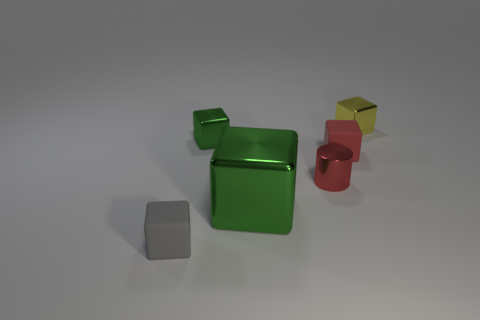Subtract all gray cubes. How many cubes are left? 4 Subtract all big green metallic blocks. How many blocks are left? 4 Subtract all cyan cubes. Subtract all blue spheres. How many cubes are left? 5 Add 1 small red shiny objects. How many objects exist? 7 Subtract all cubes. How many objects are left? 1 Add 4 tiny red rubber blocks. How many tiny red rubber blocks are left? 5 Add 3 tiny metallic cylinders. How many tiny metallic cylinders exist? 4 Subtract 0 cyan balls. How many objects are left? 6 Subtract all yellow metal cubes. Subtract all yellow cubes. How many objects are left? 4 